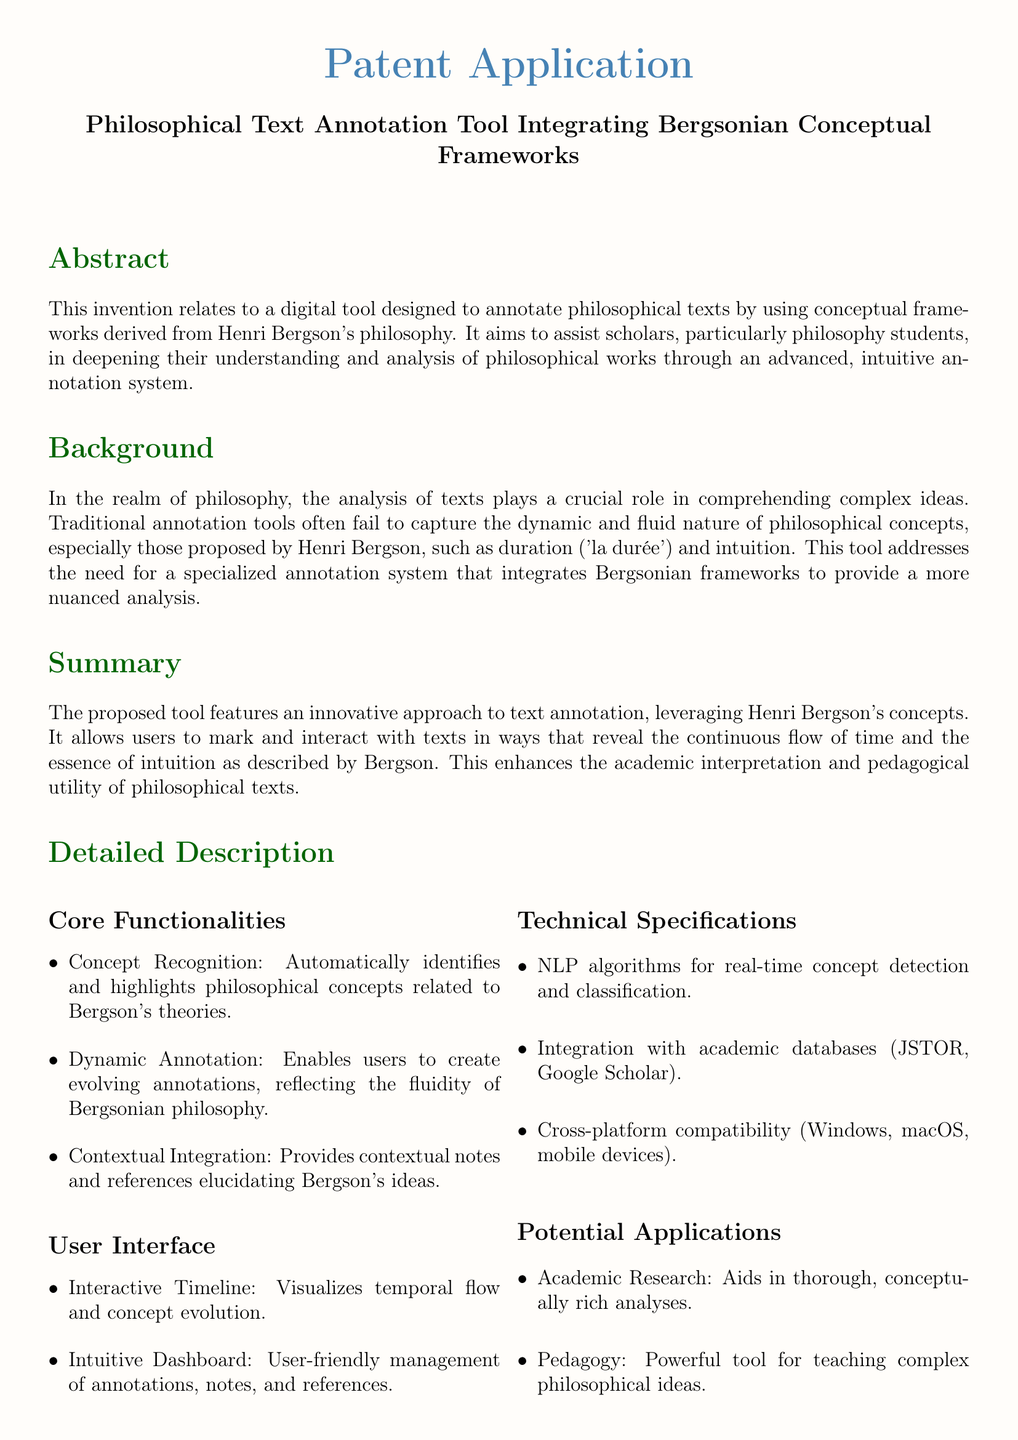What is the title of the patent application? The title is found in the header of the document.
Answer: Philosophical Text Annotation Tool Integrating Bergsonian Conceptual Frameworks Who is the inventor of the proposed tool? The inventor's name is listed at the end of the document.
Answer: Your Name Which philosophical concept is central to the tool? The abstract highlights the key concept of the tool.
Answer: Bergson's philosophy What are the two core functionalities listed? The core functionalities are explicitly mentioned in the detailed description.
Answer: Concept Recognition and Dynamic Annotation What is the purpose of the Interactive Timeline? The user interface describes the function of the Interactive Timeline.
Answer: Visualizes temporal flow and concept evolution How many claims are made in the document? The claims are listed in a numbered format.
Answer: Two What does the tool aim to enhance according to the advantages section? The advantages section outlines what the tool seeks to improve.
Answer: Understanding In which country is the inventor affiliated? The country is stated in the footer section of the document.
Answer: France What type of applications can this tool be used for? Potential applications are summarized in a bullet list.
Answer: Academic Research and Pedagogy 